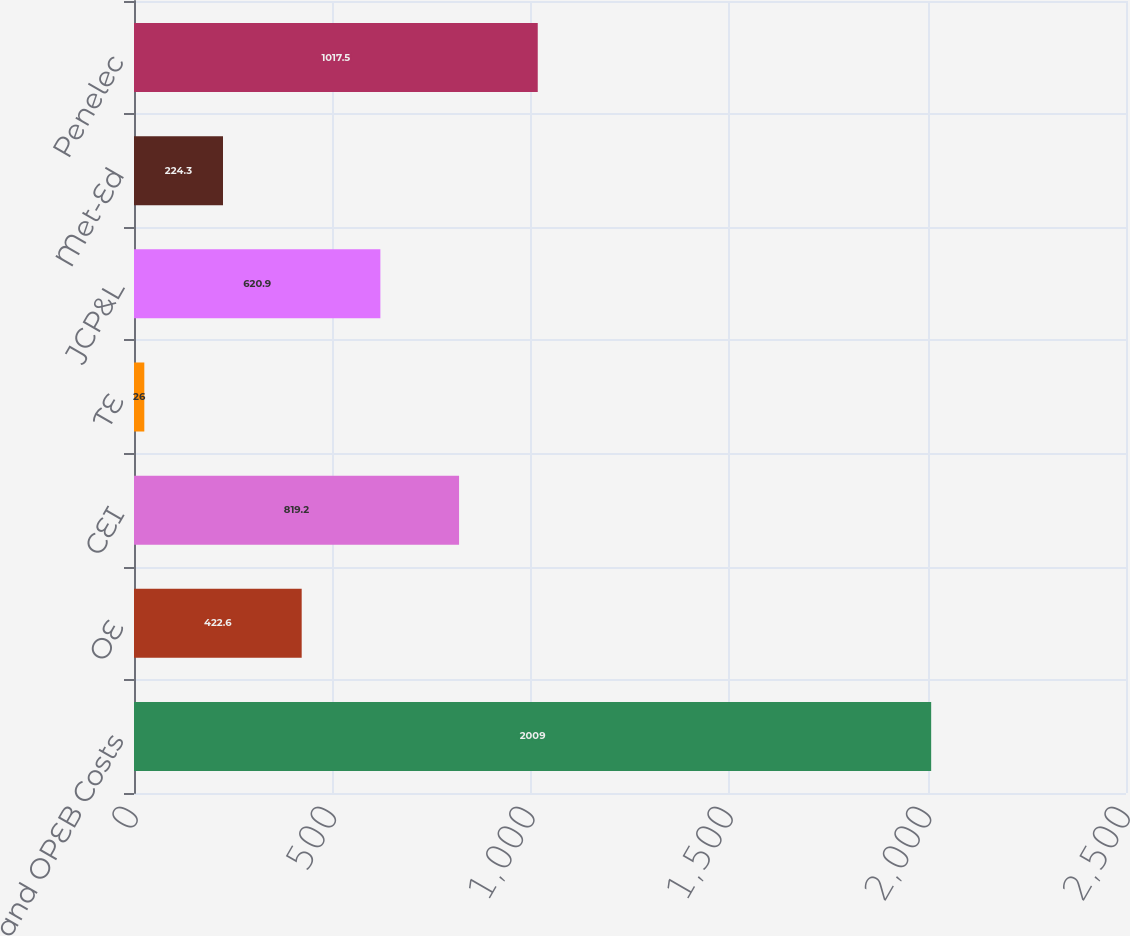Convert chart to OTSL. <chart><loc_0><loc_0><loc_500><loc_500><bar_chart><fcel>and OPEB Costs<fcel>OE<fcel>CEI<fcel>TE<fcel>JCP&L<fcel>Met-Ed<fcel>Penelec<nl><fcel>2009<fcel>422.6<fcel>819.2<fcel>26<fcel>620.9<fcel>224.3<fcel>1017.5<nl></chart> 